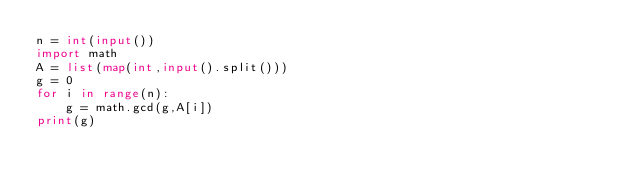<code> <loc_0><loc_0><loc_500><loc_500><_Python_>n = int(input())
import math
A = list(map(int,input().split()))
g = 0
for i in range(n):
    g = math.gcd(g,A[i])
print(g)
</code> 